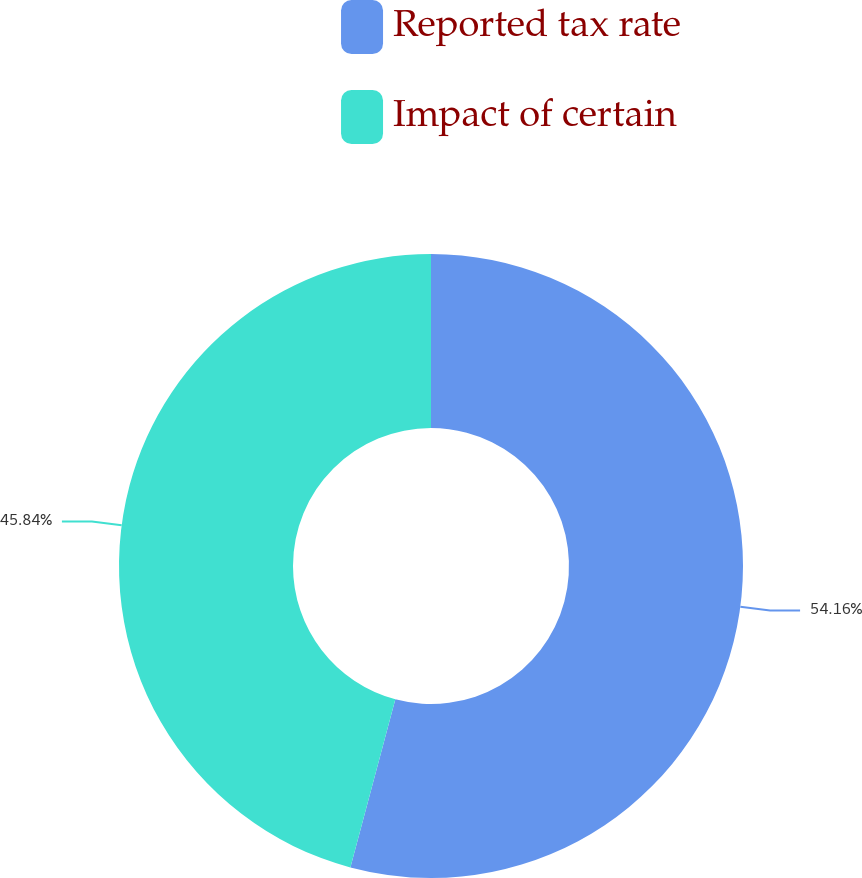Convert chart. <chart><loc_0><loc_0><loc_500><loc_500><pie_chart><fcel>Reported tax rate<fcel>Impact of certain<nl><fcel>54.16%<fcel>45.84%<nl></chart> 